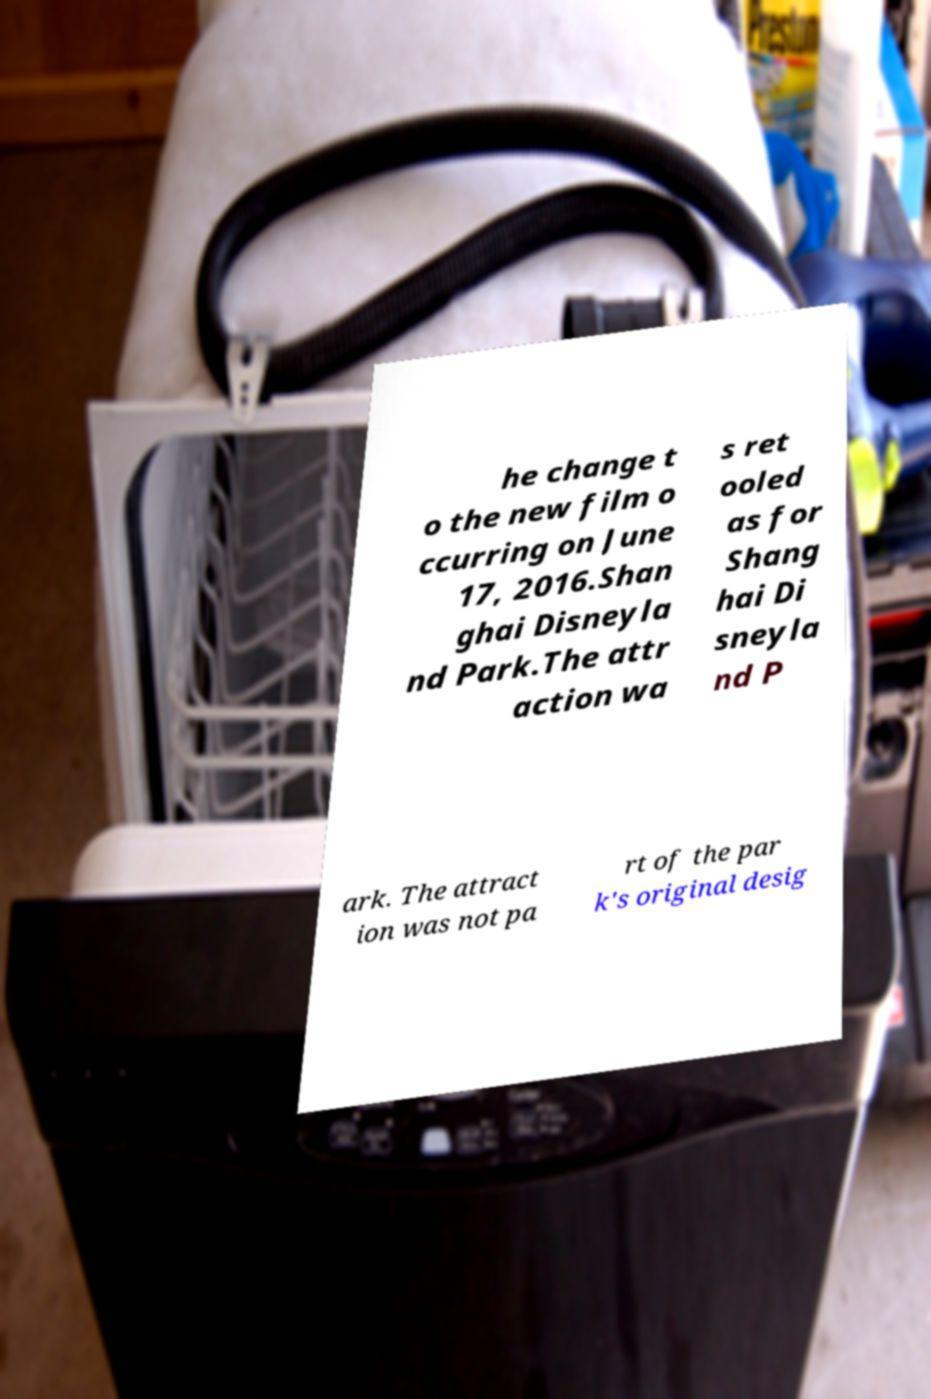Could you extract and type out the text from this image? he change t o the new film o ccurring on June 17, 2016.Shan ghai Disneyla nd Park.The attr action wa s ret ooled as for Shang hai Di sneyla nd P ark. The attract ion was not pa rt of the par k's original desig 